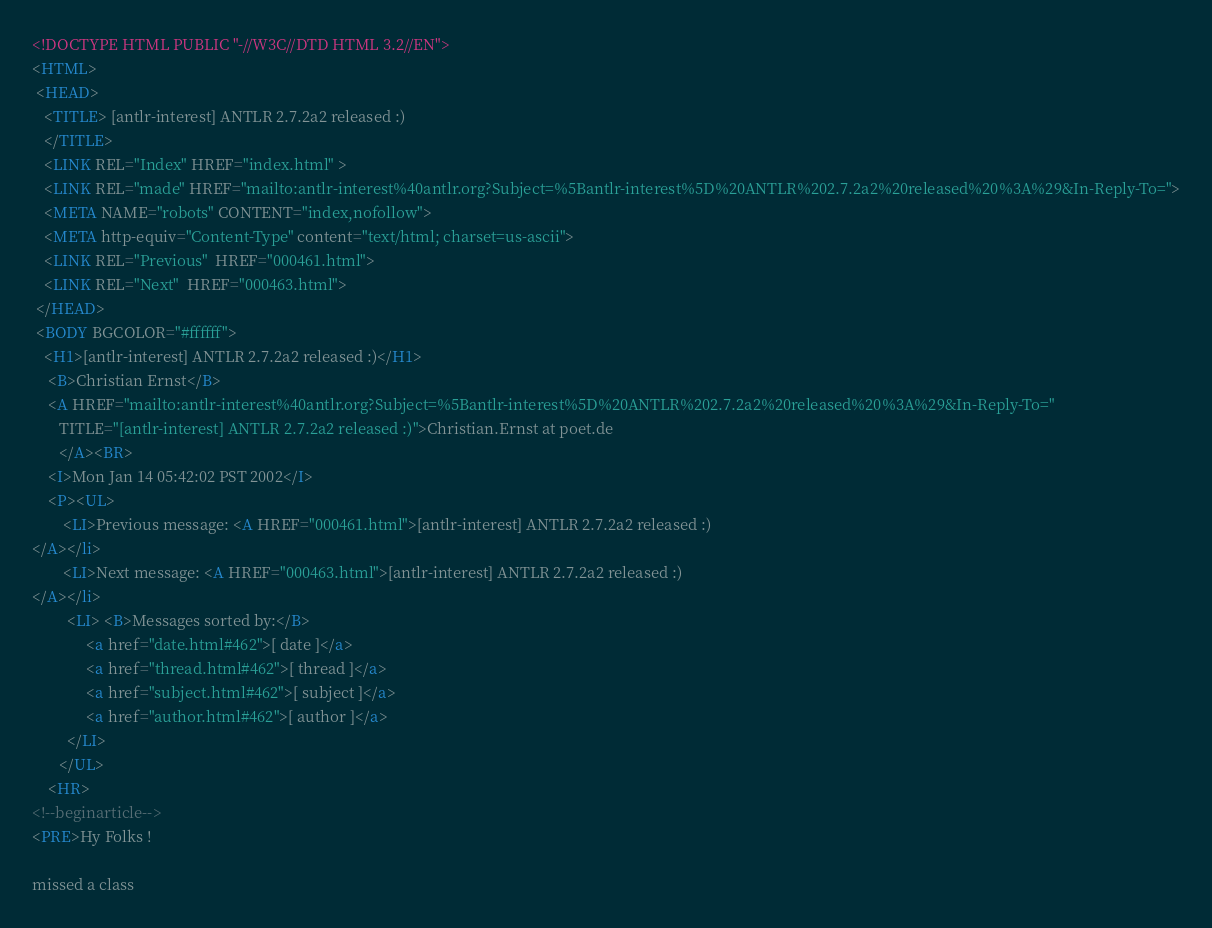Convert code to text. <code><loc_0><loc_0><loc_500><loc_500><_HTML_><!DOCTYPE HTML PUBLIC "-//W3C//DTD HTML 3.2//EN">
<HTML>
 <HEAD>
   <TITLE> [antlr-interest] ANTLR 2.7.2a2 released :)
   </TITLE>
   <LINK REL="Index" HREF="index.html" >
   <LINK REL="made" HREF="mailto:antlr-interest%40antlr.org?Subject=%5Bantlr-interest%5D%20ANTLR%202.7.2a2%20released%20%3A%29&In-Reply-To=">
   <META NAME="robots" CONTENT="index,nofollow">
   <META http-equiv="Content-Type" content="text/html; charset=us-ascii">
   <LINK REL="Previous"  HREF="000461.html">
   <LINK REL="Next"  HREF="000463.html">
 </HEAD>
 <BODY BGCOLOR="#ffffff">
   <H1>[antlr-interest] ANTLR 2.7.2a2 released :)</H1>
    <B>Christian Ernst</B> 
    <A HREF="mailto:antlr-interest%40antlr.org?Subject=%5Bantlr-interest%5D%20ANTLR%202.7.2a2%20released%20%3A%29&In-Reply-To="
       TITLE="[antlr-interest] ANTLR 2.7.2a2 released :)">Christian.Ernst at poet.de
       </A><BR>
    <I>Mon Jan 14 05:42:02 PST 2002</I>
    <P><UL>
        <LI>Previous message: <A HREF="000461.html">[antlr-interest] ANTLR 2.7.2a2 released :)
</A></li>
        <LI>Next message: <A HREF="000463.html">[antlr-interest] ANTLR 2.7.2a2 released :)
</A></li>
         <LI> <B>Messages sorted by:</B> 
              <a href="date.html#462">[ date ]</a>
              <a href="thread.html#462">[ thread ]</a>
              <a href="subject.html#462">[ subject ]</a>
              <a href="author.html#462">[ author ]</a>
         </LI>
       </UL>
    <HR>  
<!--beginarticle-->
<PRE>Hy Folks !

missed a class</code> 